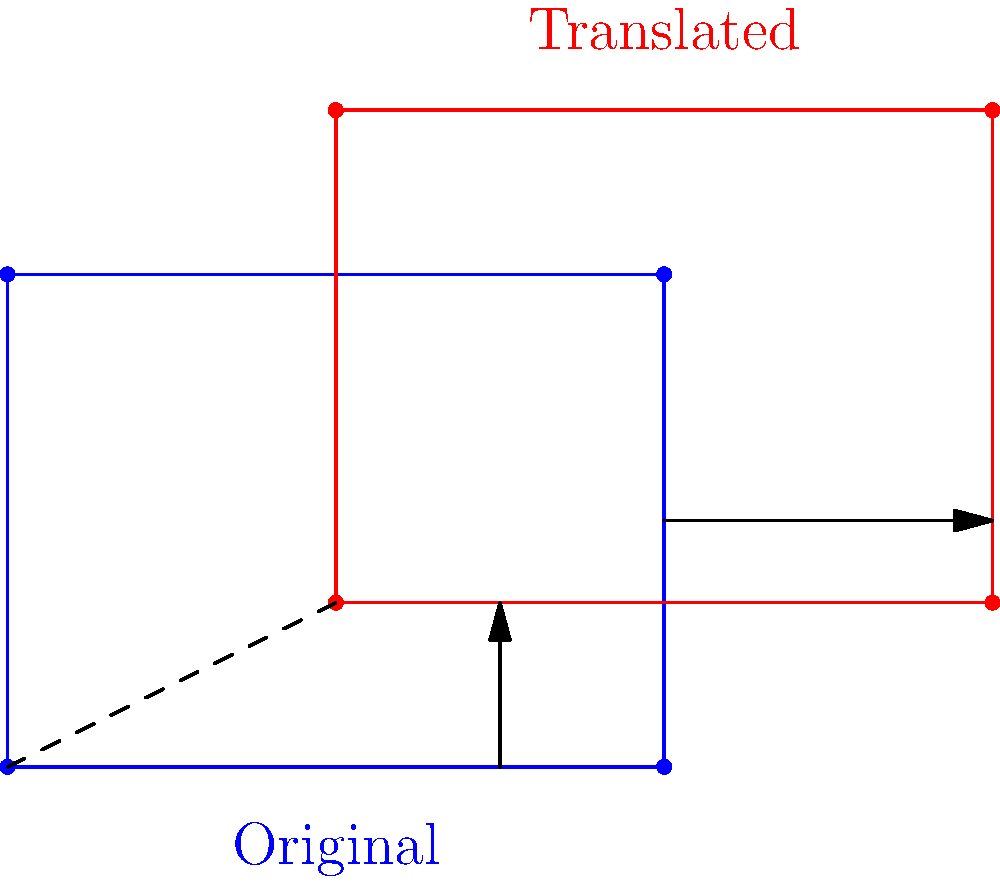In a data visualization project, you're tasked with translating a rectangle representing market share. The original rectangle (blue) has vertices at (0,0), (4,0), (4,3), and (0,3). After translation, the new rectangle (red) has its bottom-left vertex at (2,1). What is the translation vector that moves the original rectangle to its new position? To find the translation vector, we need to follow these steps:

1. Identify the coordinates of a corresponding point in both rectangles. Let's use the bottom-left vertex:
   - Original position: (0,0)
   - New position: (2,1)

2. Calculate the displacement in both x and y directions:
   - x-displacement: $2 - 0 = 2$
   - y-displacement: $1 - 0 = 1$

3. Express the translation as a vector:
   The translation vector is $\vec{v} = (2,1)$

4. Verify the translation:
   - Apply $\vec{v}$ to all vertices of the original rectangle:
     (0,0) + (2,1) = (2,1)
     (4,0) + (2,1) = (6,1)
     (4,3) + (2,1) = (6,4)
     (0,3) + (2,1) = (2,4)
   
   These coordinates match the vertices of the translated (red) rectangle.

5. Interpret the result:
   The translation vector $(2,1)$ means the rectangle has been moved 2 units right and 1 unit up.
Answer: $(2,1)$ 